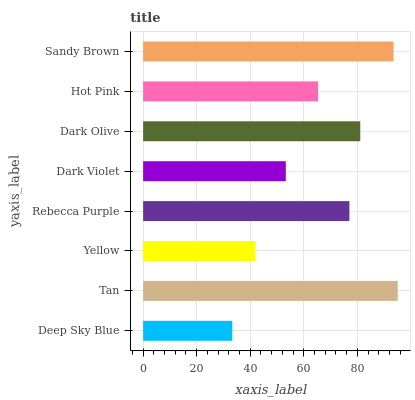Is Deep Sky Blue the minimum?
Answer yes or no. Yes. Is Tan the maximum?
Answer yes or no. Yes. Is Yellow the minimum?
Answer yes or no. No. Is Yellow the maximum?
Answer yes or no. No. Is Tan greater than Yellow?
Answer yes or no. Yes. Is Yellow less than Tan?
Answer yes or no. Yes. Is Yellow greater than Tan?
Answer yes or no. No. Is Tan less than Yellow?
Answer yes or no. No. Is Rebecca Purple the high median?
Answer yes or no. Yes. Is Hot Pink the low median?
Answer yes or no. Yes. Is Tan the high median?
Answer yes or no. No. Is Tan the low median?
Answer yes or no. No. 